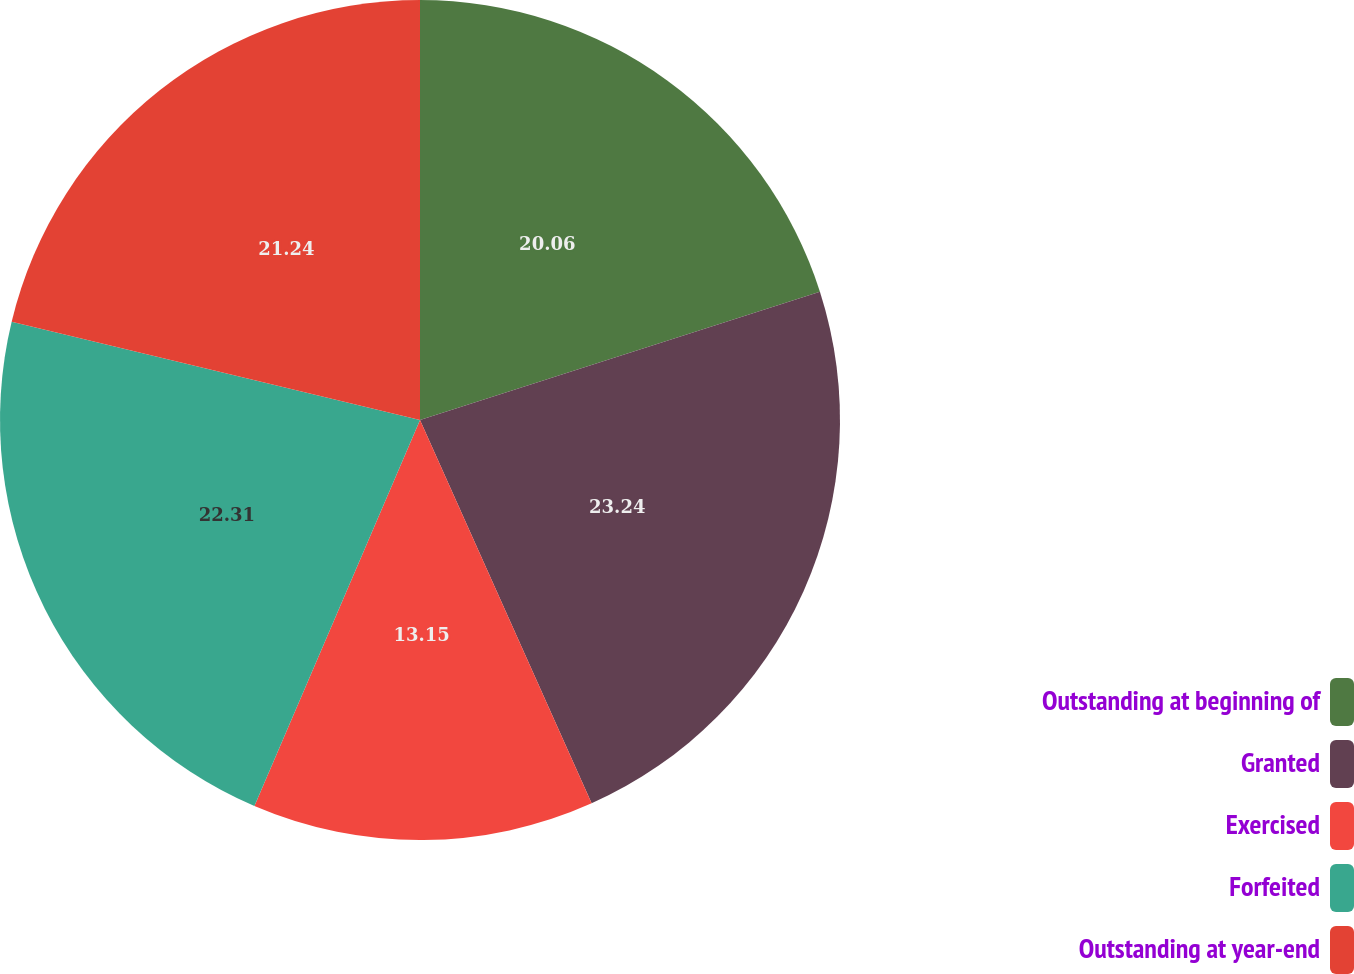Convert chart to OTSL. <chart><loc_0><loc_0><loc_500><loc_500><pie_chart><fcel>Outstanding at beginning of<fcel>Granted<fcel>Exercised<fcel>Forfeited<fcel>Outstanding at year-end<nl><fcel>20.06%<fcel>23.24%<fcel>13.15%<fcel>22.31%<fcel>21.24%<nl></chart> 